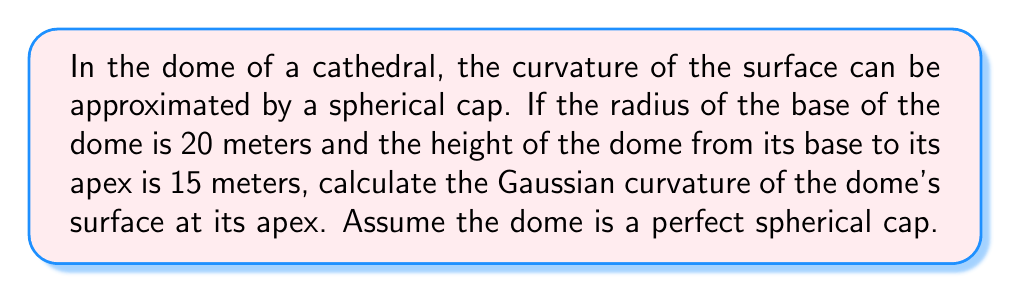Provide a solution to this math problem. Let's approach this step-by-step:

1) First, we need to find the radius of the sphere that this spherical cap is a part of. We can do this using the equation:

   $$ r^2 = h(2R - h) $$

   Where $r$ is the radius of the base, $h$ is the height of the dome, and $R$ is the radius of the sphere.

2) Substituting our known values:

   $$ 20^2 = 15(2R - 15) $$

3) Simplify:

   $$ 400 = 30R - 225 $$

4) Solve for $R$:

   $$ 625 = 30R $$
   $$ R = \frac{625}{30} \approx 20.83 \text{ meters} $$

5) Now that we have the radius of the sphere, we can calculate the Gaussian curvature. For a sphere, the Gaussian curvature is constant at every point and is given by:

   $$ K = \frac{1}{R^2} $$

6) Substituting our value for $R$:

   $$ K = \frac{1}{(20.83)^2} \approx 0.0023 \text{ m}^{-2} $$

This is the Gaussian curvature at every point on the dome, including the apex.
Answer: $0.0023 \text{ m}^{-2}$ 